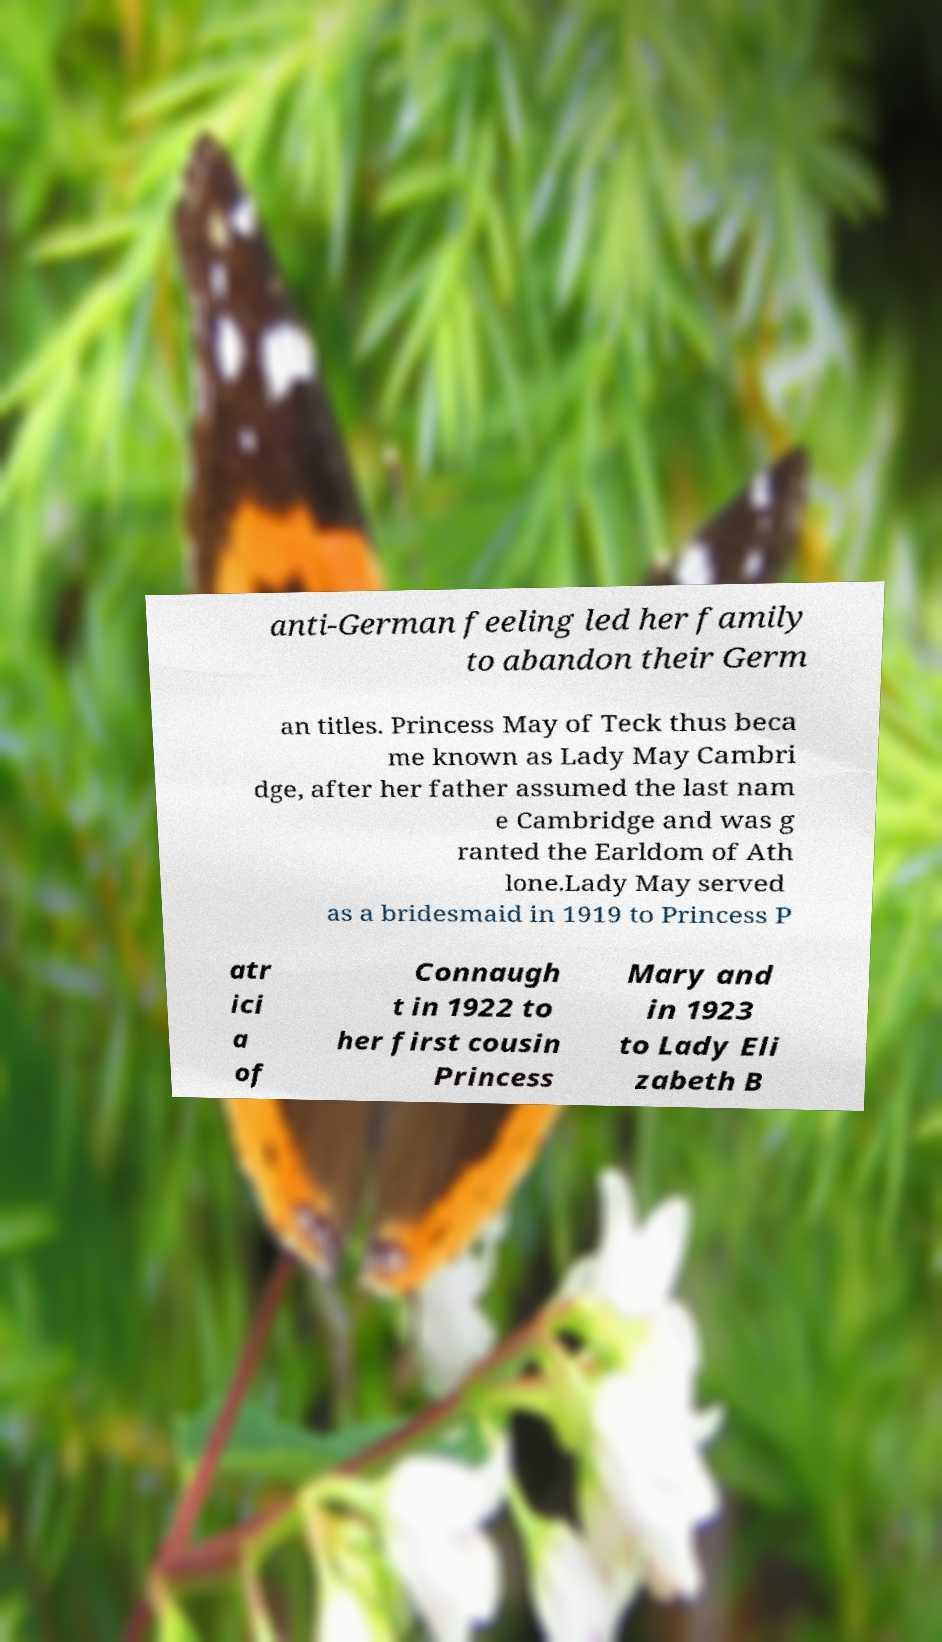Can you read and provide the text displayed in the image?This photo seems to have some interesting text. Can you extract and type it out for me? anti-German feeling led her family to abandon their Germ an titles. Princess May of Teck thus beca me known as Lady May Cambri dge, after her father assumed the last nam e Cambridge and was g ranted the Earldom of Ath lone.Lady May served as a bridesmaid in 1919 to Princess P atr ici a of Connaugh t in 1922 to her first cousin Princess Mary and in 1923 to Lady Eli zabeth B 